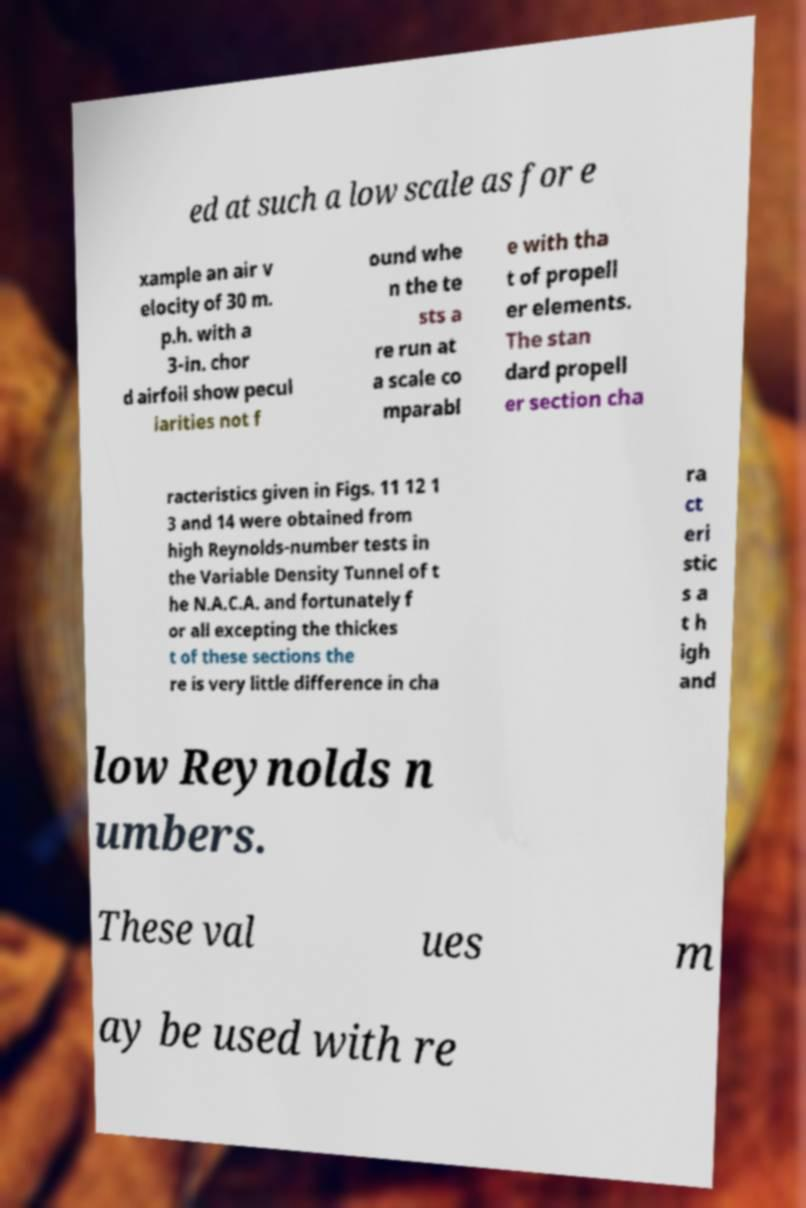For documentation purposes, I need the text within this image transcribed. Could you provide that? ed at such a low scale as for e xample an air v elocity of 30 m. p.h. with a 3-in. chor d airfoil show pecul iarities not f ound whe n the te sts a re run at a scale co mparabl e with tha t of propell er elements. The stan dard propell er section cha racteristics given in Figs. 11 12 1 3 and 14 were obtained from high Reynolds-number tests in the Variable Density Tunnel of t he N.A.C.A. and fortunately f or all excepting the thickes t of these sections the re is very little difference in cha ra ct eri stic s a t h igh and low Reynolds n umbers. These val ues m ay be used with re 